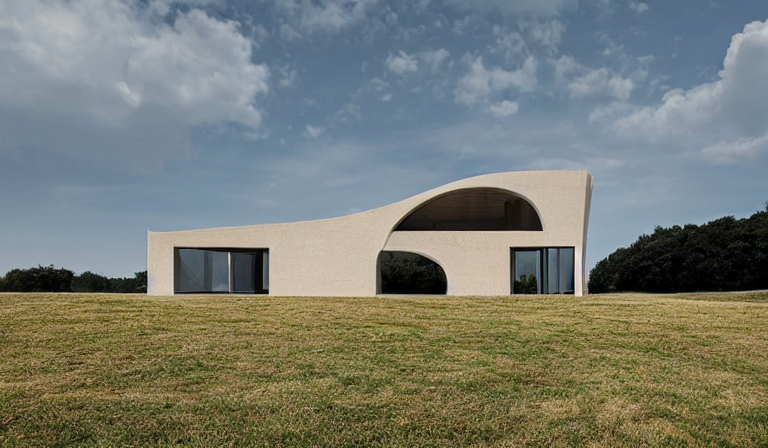Are the colors in the image abundant? The image showcases a building set against a vibrant sky and verdant landscape. While the colors are not abundant in terms of variety, with primarily hues of blue, green, and the earthy tone of the building, the saturation and contrast convey a sense of richness and depth. 